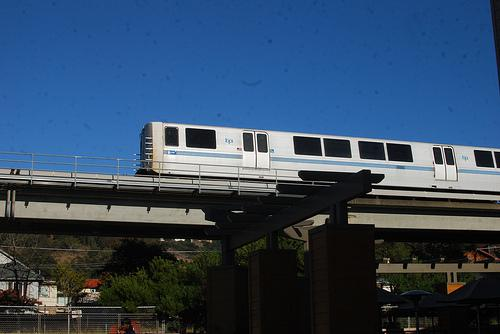Question: what is on the bridge?
Choices:
A. Cars.
B. Marchers.
C. A truck.
D. Train.
Answer with the letter. Answer: D Question: what color is the train?
Choices:
A. Brown.
B. Red.
C. Silver and blue.
D. Green.
Answer with the letter. Answer: C Question: how many windows are there?
Choices:
A. Four.
B. Twelve.
C. Six.
D. Eight.
Answer with the letter. Answer: B 